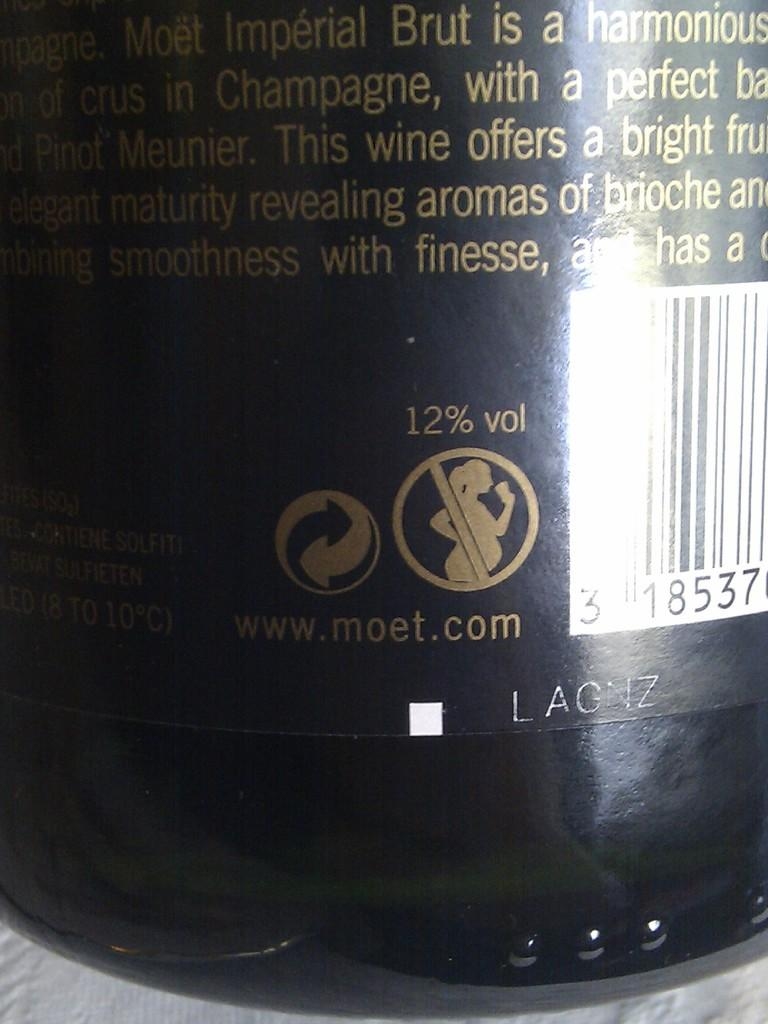<image>
Offer a succinct explanation of the picture presented. The back of a Moet wine showing it is 12% vol alcohol. 